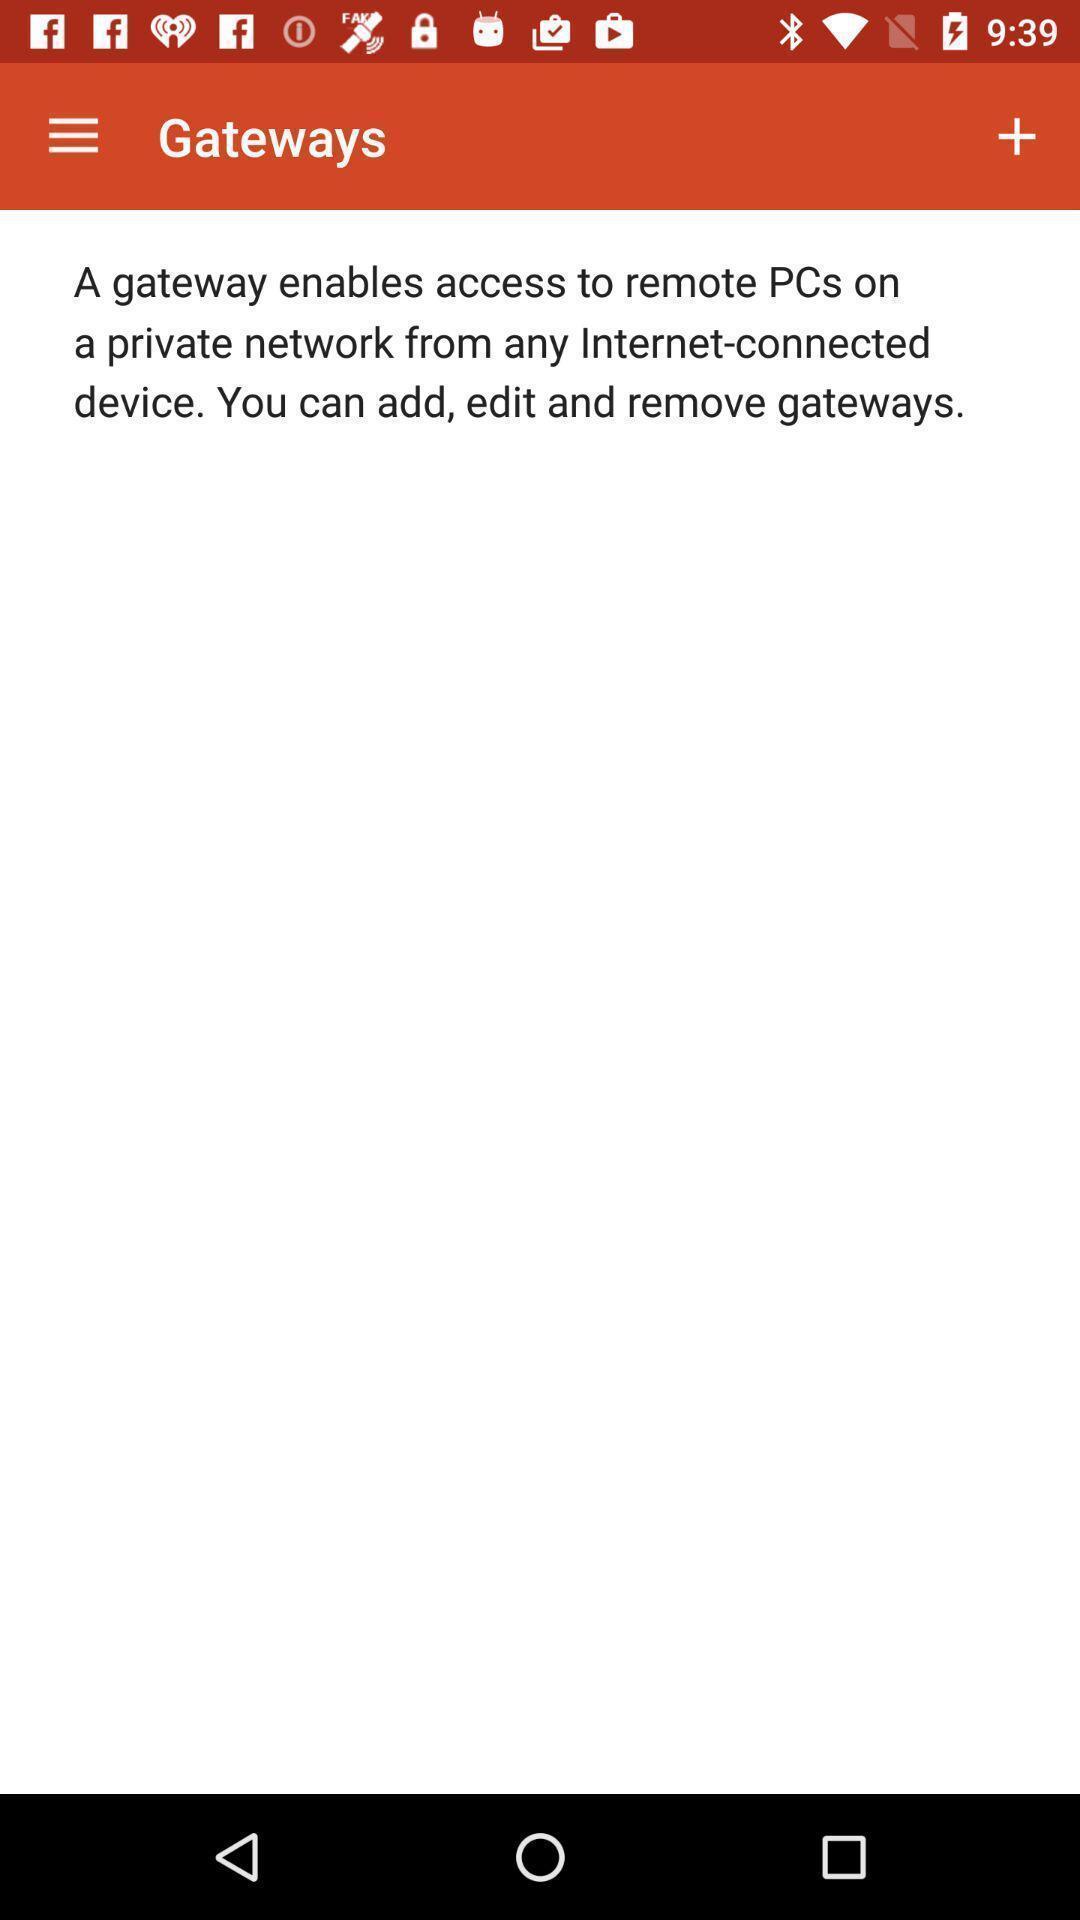Provide a textual representation of this image. Page displays about an app. 